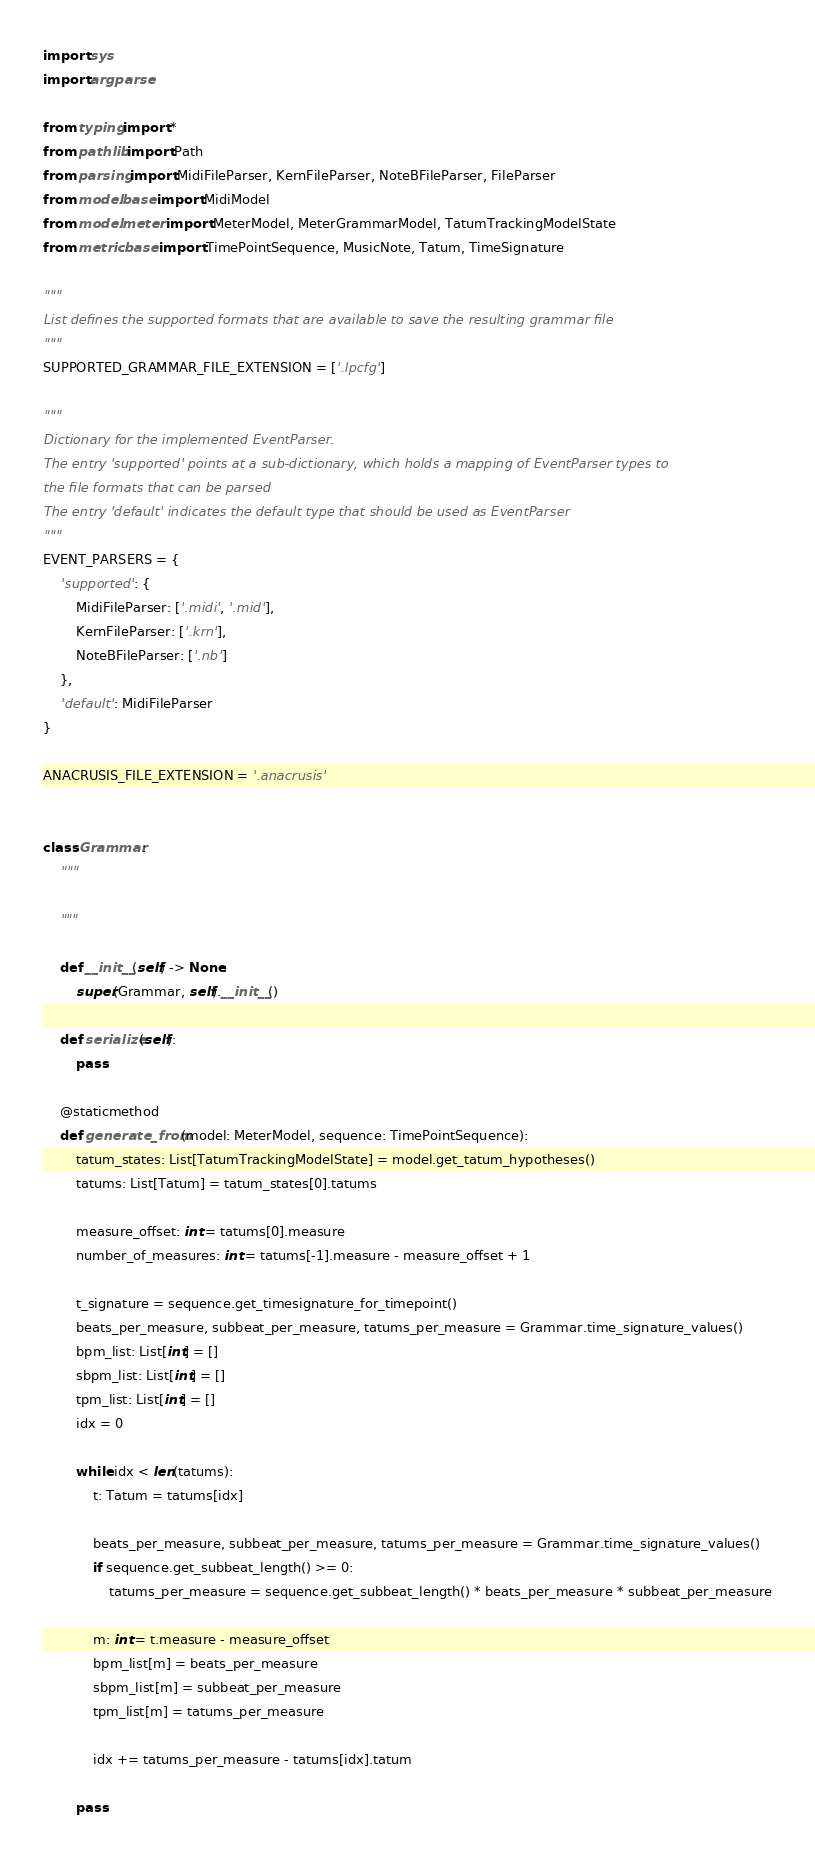Convert code to text. <code><loc_0><loc_0><loc_500><loc_500><_Python_>import sys
import argparse

from typing import *
from pathlib import Path
from parsing import MidiFileParser, KernFileParser, NoteBFileParser, FileParser
from model.base import MidiModel
from model.meter import MeterModel, MeterGrammarModel, TatumTrackingModelState
from metric.base import TimePointSequence, MusicNote, Tatum, TimeSignature

""" 
List defines the supported formats that are available to save the resulting grammar file
"""
SUPPORTED_GRAMMAR_FILE_EXTENSION = ['.lpcfg']

"""
Dictionary for the implemented EventParser. 
The entry 'supported' points at a sub-dictionary, which holds a mapping of EventParser types to 
the file formats that can be parsed
The entry 'default' indicates the default type that should be used as EventParser
"""
EVENT_PARSERS = {
    'supported': {
        MidiFileParser: ['.midi', '.mid'],
        KernFileParser: ['.krn'],
        NoteBFileParser: ['.nb']
    },
    'default': MidiFileParser
}

ANACRUSIS_FILE_EXTENSION = '.anacrusis'


class Grammar:
    """

    """

    def __init__(self) -> None:
        super(Grammar, self).__init__()

    def serialize(self):
        pass

    @staticmethod
    def generate_from(model: MeterModel, sequence: TimePointSequence):
        tatum_states: List[TatumTrackingModelState] = model.get_tatum_hypotheses()
        tatums: List[Tatum] = tatum_states[0].tatums

        measure_offset: int = tatums[0].measure
        number_of_measures: int = tatums[-1].measure - measure_offset + 1

        t_signature = sequence.get_timesignature_for_timepoint()
        beats_per_measure, subbeat_per_measure, tatums_per_measure = Grammar.time_signature_values()
        bpm_list: List[int] = []
        sbpm_list: List[int] = []
        tpm_list: List[int] = []
        idx = 0

        while idx < len(tatums):
            t: Tatum = tatums[idx]

            beats_per_measure, subbeat_per_measure, tatums_per_measure = Grammar.time_signature_values()
            if sequence.get_subbeat_length() >= 0:
                tatums_per_measure = sequence.get_subbeat_length() * beats_per_measure * subbeat_per_measure

            m: int = t.measure - measure_offset
            bpm_list[m] = beats_per_measure
            sbpm_list[m] = subbeat_per_measure
            tpm_list[m] = tatums_per_measure

            idx += tatums_per_measure - tatums[idx].tatum

        pass
</code> 